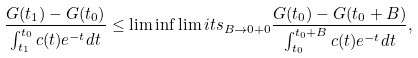<formula> <loc_0><loc_0><loc_500><loc_500>\frac { G ( t _ { 1 } ) - G ( t _ { 0 } ) } { \int ^ { t _ { 0 } } _ { t _ { 1 } } c ( t ) e ^ { - t } d t } \leq \liminf \lim i t s _ { B \to 0 + 0 } \frac { G ( t _ { 0 } ) - G ( t _ { 0 } + B ) } { \int _ { t _ { 0 } } ^ { t _ { 0 } + B } c ( t ) e ^ { - t } d t } ,</formula> 